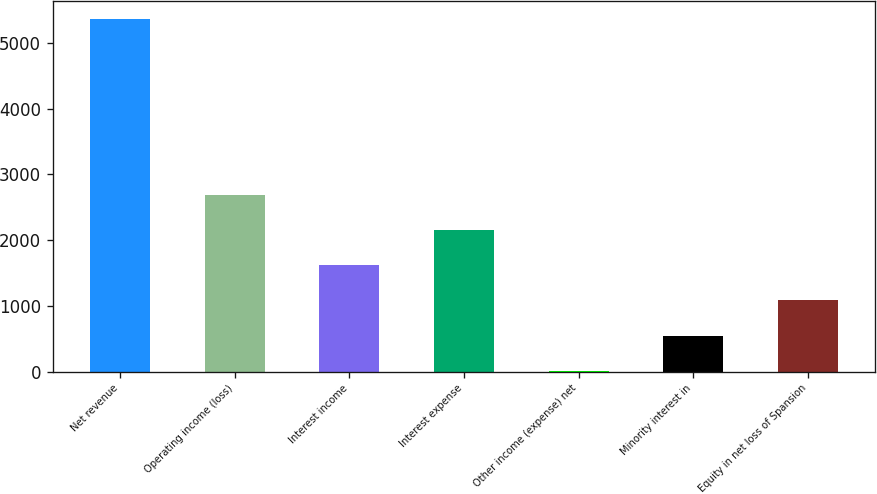Convert chart. <chart><loc_0><loc_0><loc_500><loc_500><bar_chart><fcel>Net revenue<fcel>Operating income (loss)<fcel>Interest income<fcel>Interest expense<fcel>Other income (expense) net<fcel>Minority interest in<fcel>Equity in net loss of Spansion<nl><fcel>5367<fcel>2690<fcel>1619.2<fcel>2154.6<fcel>13<fcel>548.4<fcel>1083.8<nl></chart> 